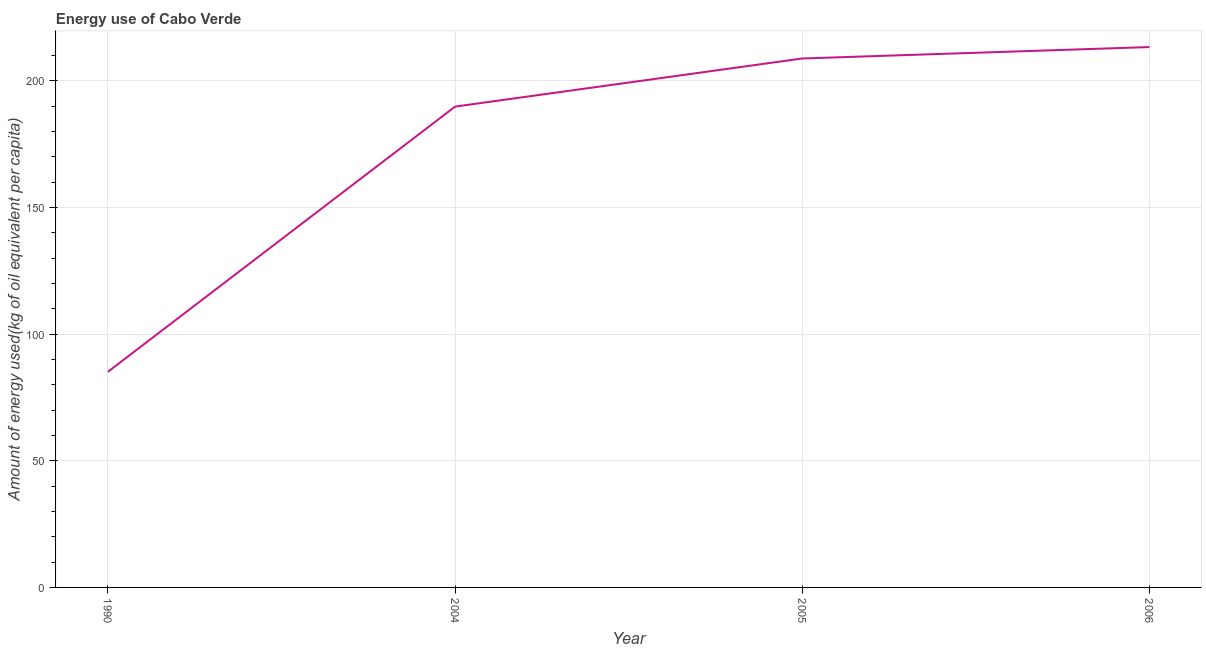What is the amount of energy used in 2004?
Your answer should be very brief. 189.77. Across all years, what is the maximum amount of energy used?
Your response must be concise. 213.27. Across all years, what is the minimum amount of energy used?
Offer a very short reply. 85.12. In which year was the amount of energy used maximum?
Provide a short and direct response. 2006. In which year was the amount of energy used minimum?
Provide a succinct answer. 1990. What is the sum of the amount of energy used?
Your answer should be very brief. 696.92. What is the difference between the amount of energy used in 2005 and 2006?
Provide a short and direct response. -4.51. What is the average amount of energy used per year?
Give a very brief answer. 174.23. What is the median amount of energy used?
Keep it short and to the point. 199.27. In how many years, is the amount of energy used greater than 130 kg?
Your response must be concise. 3. What is the ratio of the amount of energy used in 1990 to that in 2005?
Your response must be concise. 0.41. What is the difference between the highest and the second highest amount of energy used?
Offer a very short reply. 4.51. Is the sum of the amount of energy used in 1990 and 2006 greater than the maximum amount of energy used across all years?
Your answer should be compact. Yes. What is the difference between the highest and the lowest amount of energy used?
Provide a succinct answer. 128.16. In how many years, is the amount of energy used greater than the average amount of energy used taken over all years?
Your answer should be compact. 3. How many years are there in the graph?
Give a very brief answer. 4. What is the difference between two consecutive major ticks on the Y-axis?
Your answer should be very brief. 50. Are the values on the major ticks of Y-axis written in scientific E-notation?
Your answer should be compact. No. Does the graph contain any zero values?
Ensure brevity in your answer.  No. Does the graph contain grids?
Your answer should be very brief. Yes. What is the title of the graph?
Provide a succinct answer. Energy use of Cabo Verde. What is the label or title of the X-axis?
Make the answer very short. Year. What is the label or title of the Y-axis?
Offer a very short reply. Amount of energy used(kg of oil equivalent per capita). What is the Amount of energy used(kg of oil equivalent per capita) in 1990?
Your response must be concise. 85.12. What is the Amount of energy used(kg of oil equivalent per capita) of 2004?
Give a very brief answer. 189.77. What is the Amount of energy used(kg of oil equivalent per capita) in 2005?
Your answer should be compact. 208.76. What is the Amount of energy used(kg of oil equivalent per capita) of 2006?
Your response must be concise. 213.27. What is the difference between the Amount of energy used(kg of oil equivalent per capita) in 1990 and 2004?
Keep it short and to the point. -104.66. What is the difference between the Amount of energy used(kg of oil equivalent per capita) in 1990 and 2005?
Offer a terse response. -123.65. What is the difference between the Amount of energy used(kg of oil equivalent per capita) in 1990 and 2006?
Provide a short and direct response. -128.16. What is the difference between the Amount of energy used(kg of oil equivalent per capita) in 2004 and 2005?
Your answer should be very brief. -18.99. What is the difference between the Amount of energy used(kg of oil equivalent per capita) in 2004 and 2006?
Your answer should be compact. -23.5. What is the difference between the Amount of energy used(kg of oil equivalent per capita) in 2005 and 2006?
Offer a very short reply. -4.51. What is the ratio of the Amount of energy used(kg of oil equivalent per capita) in 1990 to that in 2004?
Provide a short and direct response. 0.45. What is the ratio of the Amount of energy used(kg of oil equivalent per capita) in 1990 to that in 2005?
Provide a succinct answer. 0.41. What is the ratio of the Amount of energy used(kg of oil equivalent per capita) in 1990 to that in 2006?
Offer a very short reply. 0.4. What is the ratio of the Amount of energy used(kg of oil equivalent per capita) in 2004 to that in 2005?
Your answer should be very brief. 0.91. What is the ratio of the Amount of energy used(kg of oil equivalent per capita) in 2004 to that in 2006?
Provide a short and direct response. 0.89. 